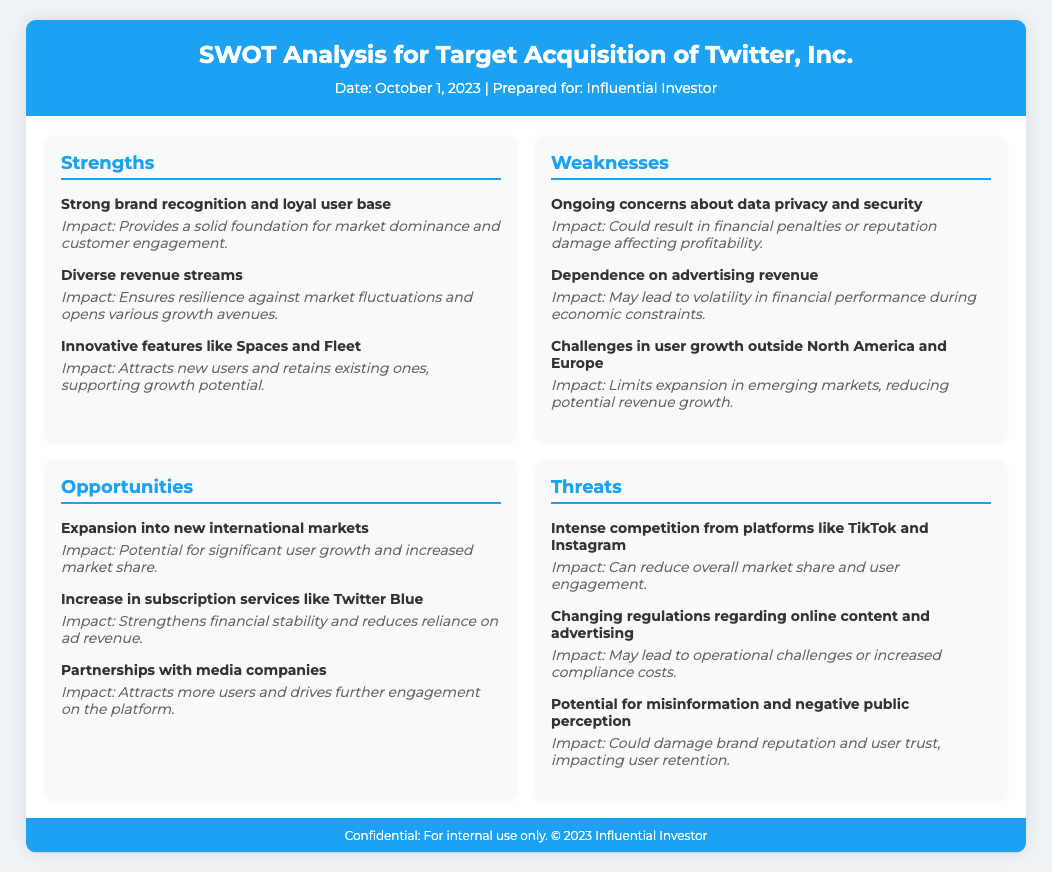What is the date of the SWOT analysis? The date provided in the document is detailed in the header section.
Answer: October 1, 2023 Who is the SWOT analysis prepared for? The document states who it is prepared for, mentioned in the header.
Answer: Influential Investor What are the three main strengths highlighted? The strengths section lists three key strengths of Twitter, Inc.
Answer: Strong brand recognition and loyal user base, Diverse revenue streams, Innovative features like Spaces and Fleet What is one of the weaknesses related to revenue? The weaknesses section highlights a specific financial related weakness mentioned.
Answer: Dependence on advertising revenue Name one opportunity for Twitter, Inc. The opportunities section lists various growth potentials for Twitter, reflecting market strategies.
Answer: Expansion into new international markets What is one threat posed by competitors? The threats section specifically mentions competitive pressures within the market.
Answer: Intense competition from platforms like TikTok and Instagram How many opportunities are listed in the document? The opportunities section indicates the count of strategic growth options available.
Answer: Three What impact does data privacy have on Twitter, Inc.? One of the weaknesses discusses the consequences of data privacy issues on the company.
Answer: Could result in financial penalties or reputation damage affecting profitability What impact does expanding subscription services have? The opportunities section discusses the specific financial benefits of increasing subscription services.
Answer: Strengthens financial stability and reduces reliance on ad revenue 